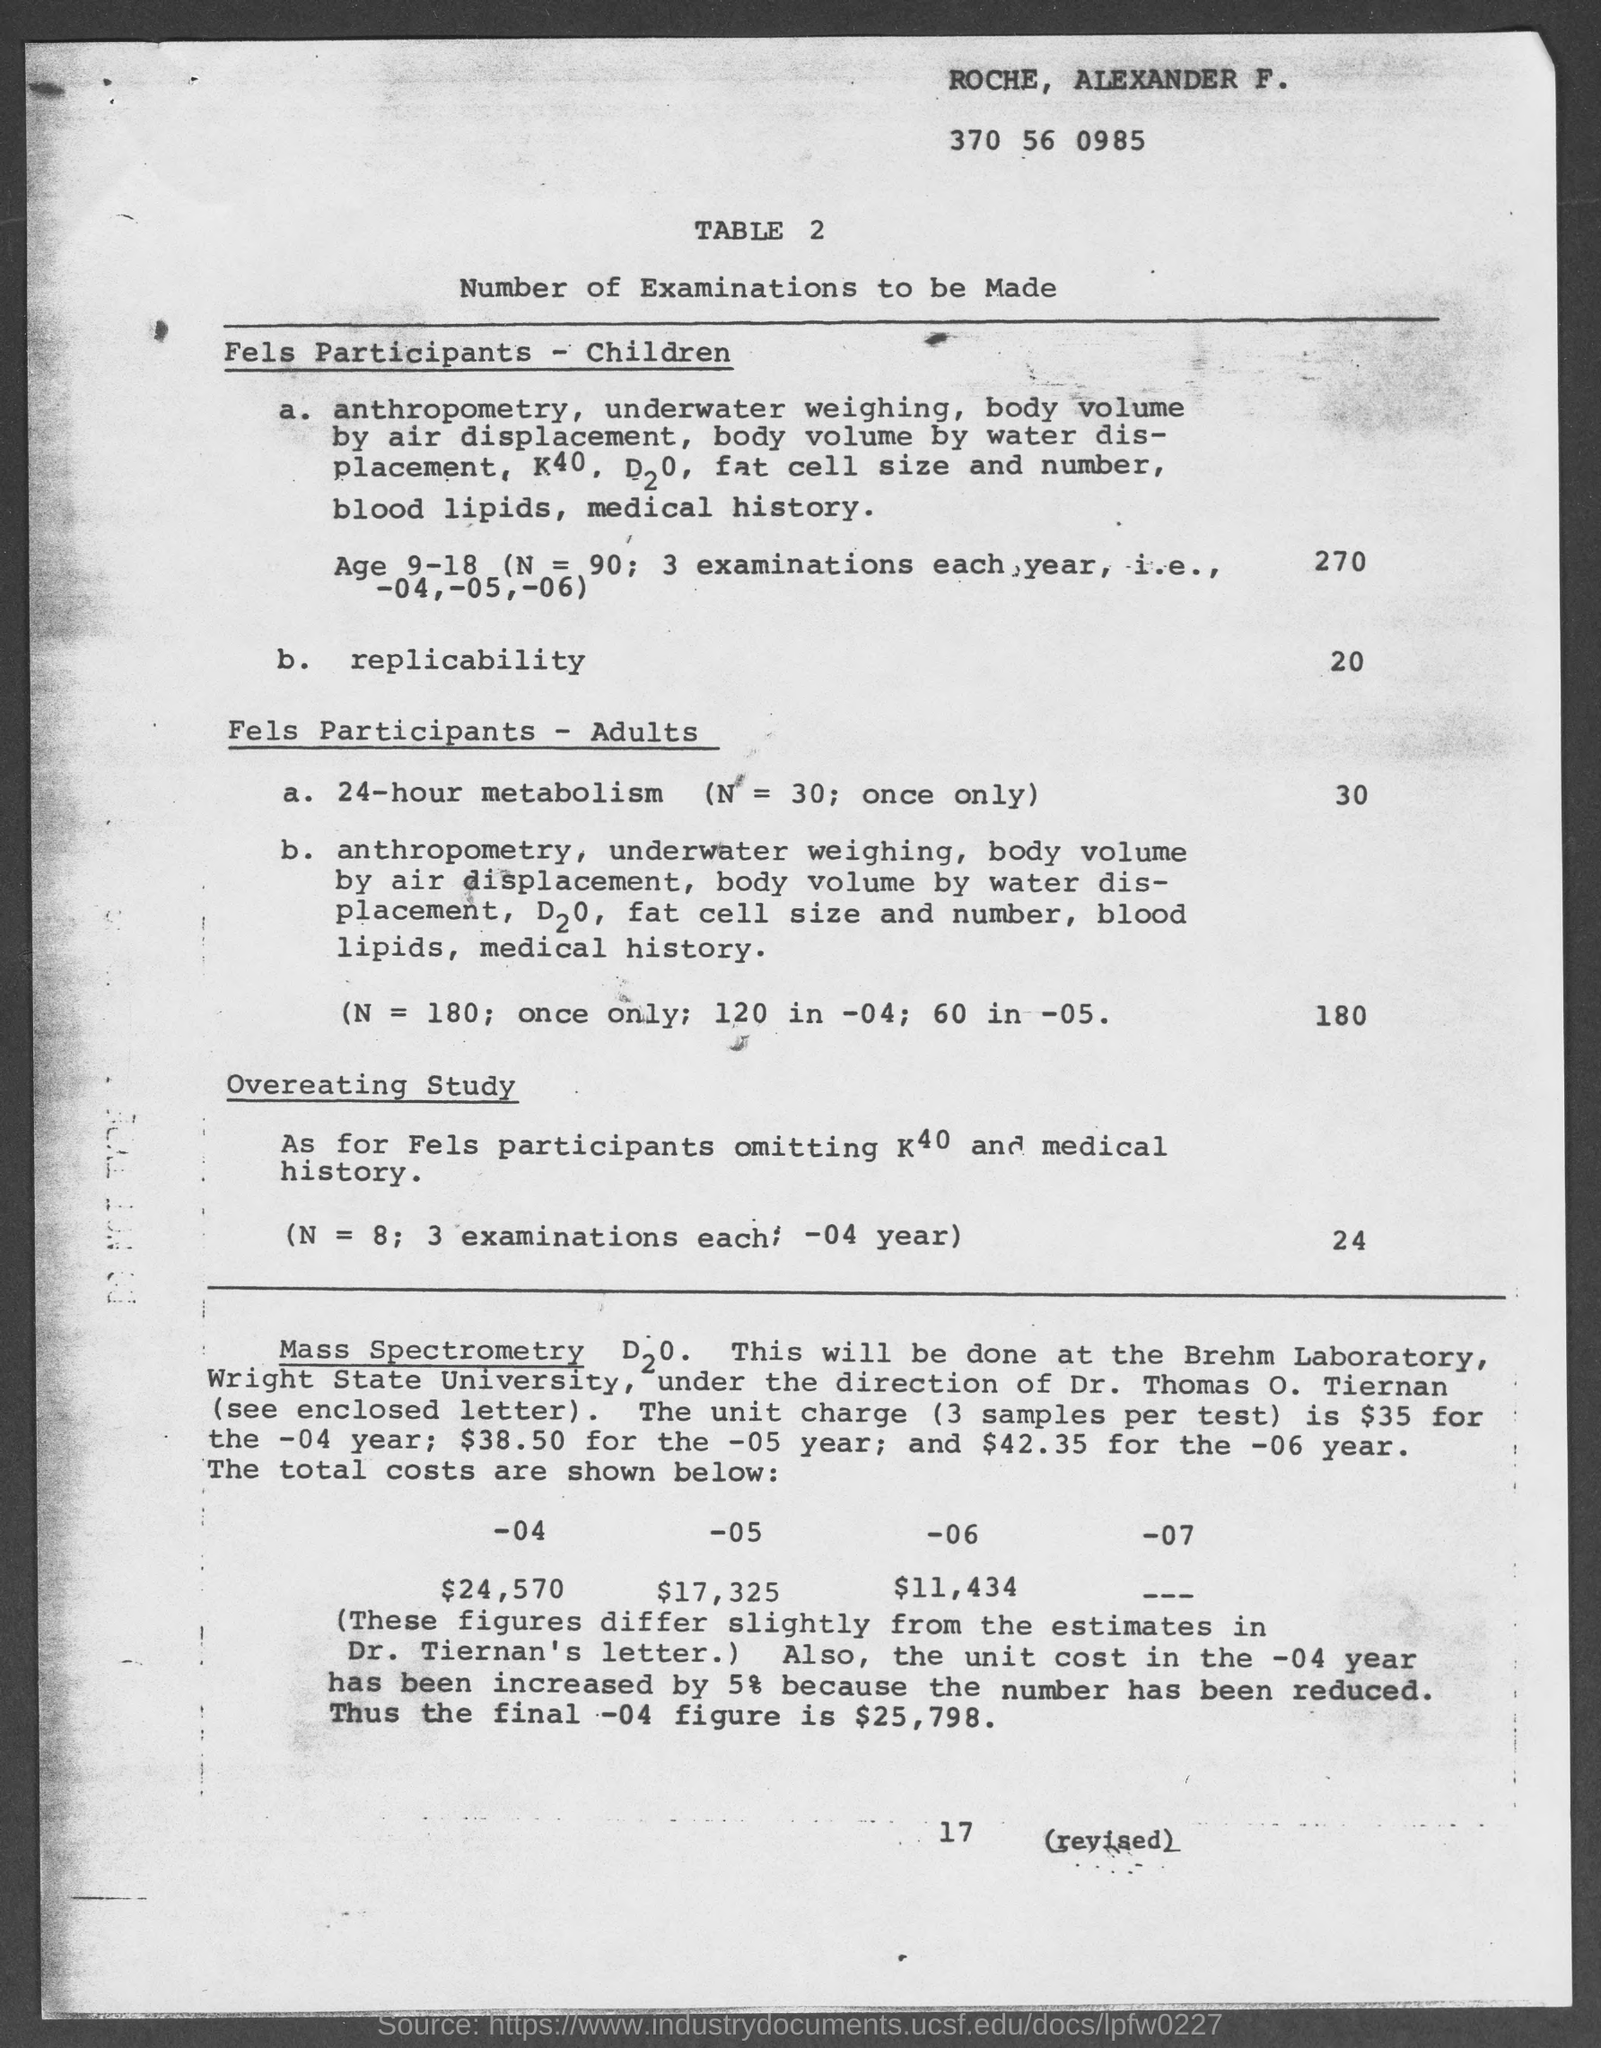List a handful of essential elements in this visual. The document bears the name ROCHE, ALEXANDER F at the top. The table number is 2. 